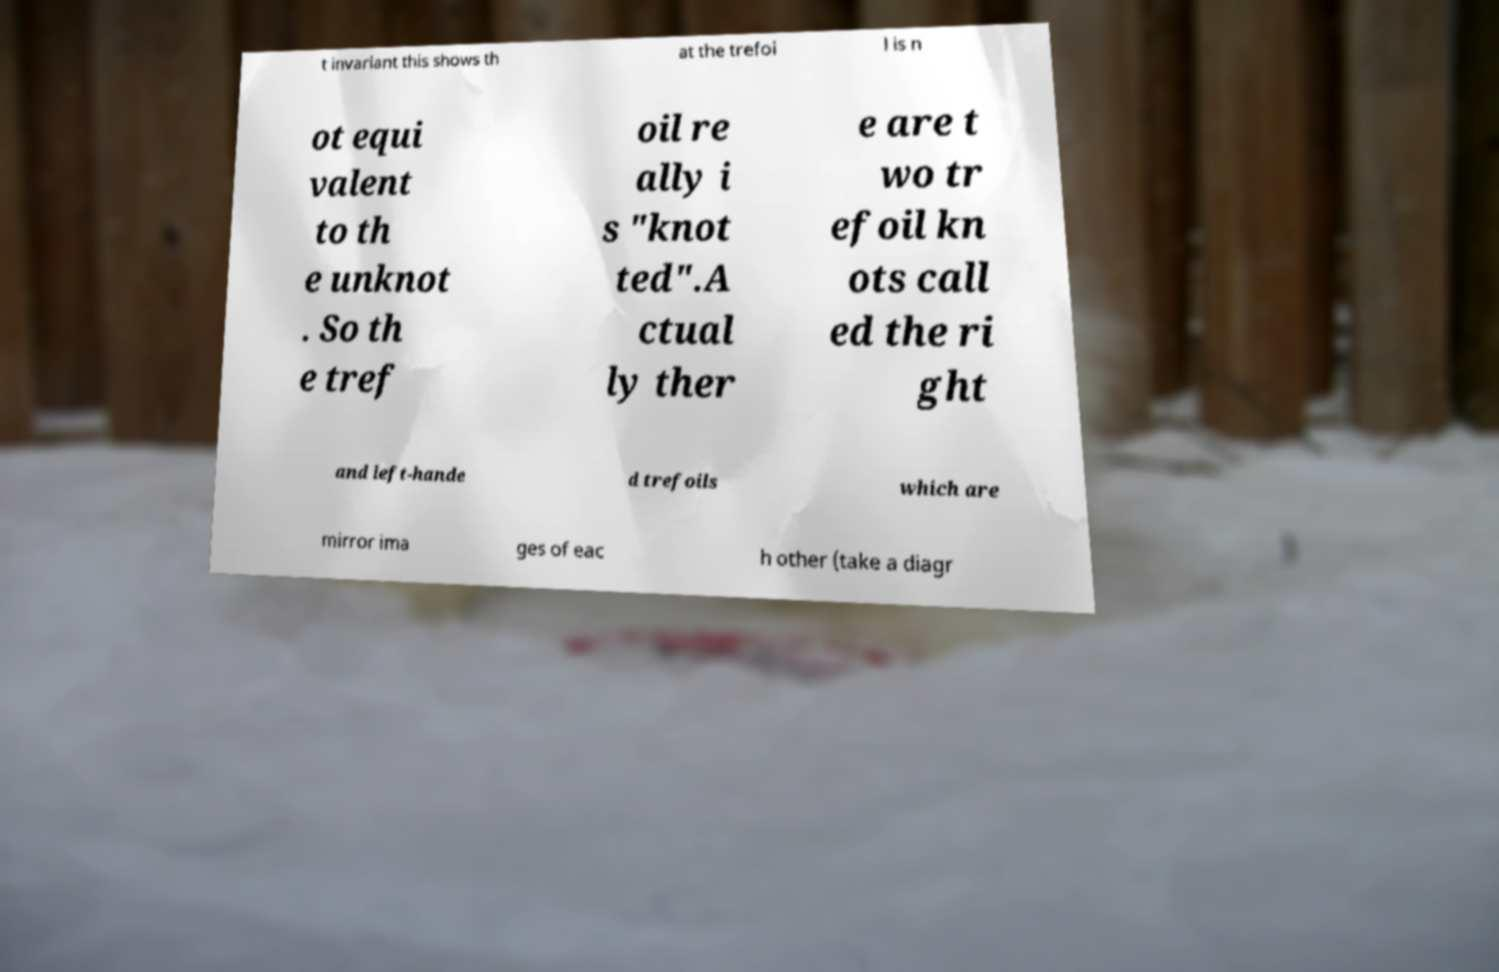Please read and relay the text visible in this image. What does it say? t invariant this shows th at the trefoi l is n ot equi valent to th e unknot . So th e tref oil re ally i s "knot ted".A ctual ly ther e are t wo tr efoil kn ots call ed the ri ght and left-hande d trefoils which are mirror ima ges of eac h other (take a diagr 